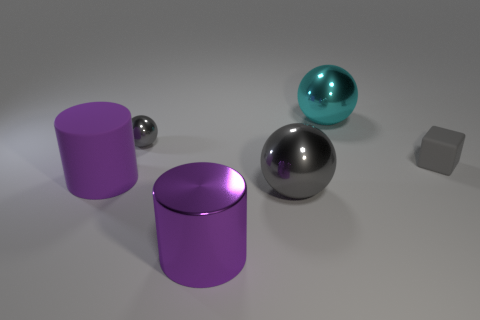Add 3 large gray things. How many objects exist? 9 Subtract all blocks. How many objects are left? 5 Subtract all gray things. Subtract all small cyan balls. How many objects are left? 3 Add 5 large purple things. How many large purple things are left? 7 Add 5 gray metallic blocks. How many gray metallic blocks exist? 5 Subtract 1 gray cubes. How many objects are left? 5 